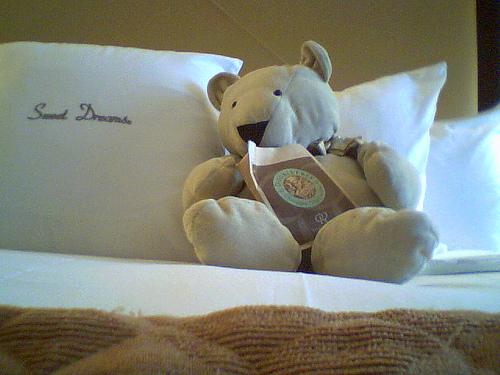What is around the teddy bear's hand?
Be succinct. Nothing. Why is the bear holding baby items?
Answer briefly. Don't know. What does the pillow say?
Short answer required. Sweet dreams. How many toys are there?
Write a very short answer. 1. What color is the bear?
Short answer required. Tan. Do these stuffed animals have names?
Write a very short answer. Yes. Could this bear ruin your campsite?
Be succinct. No. 